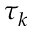<formula> <loc_0><loc_0><loc_500><loc_500>\tau _ { k }</formula> 